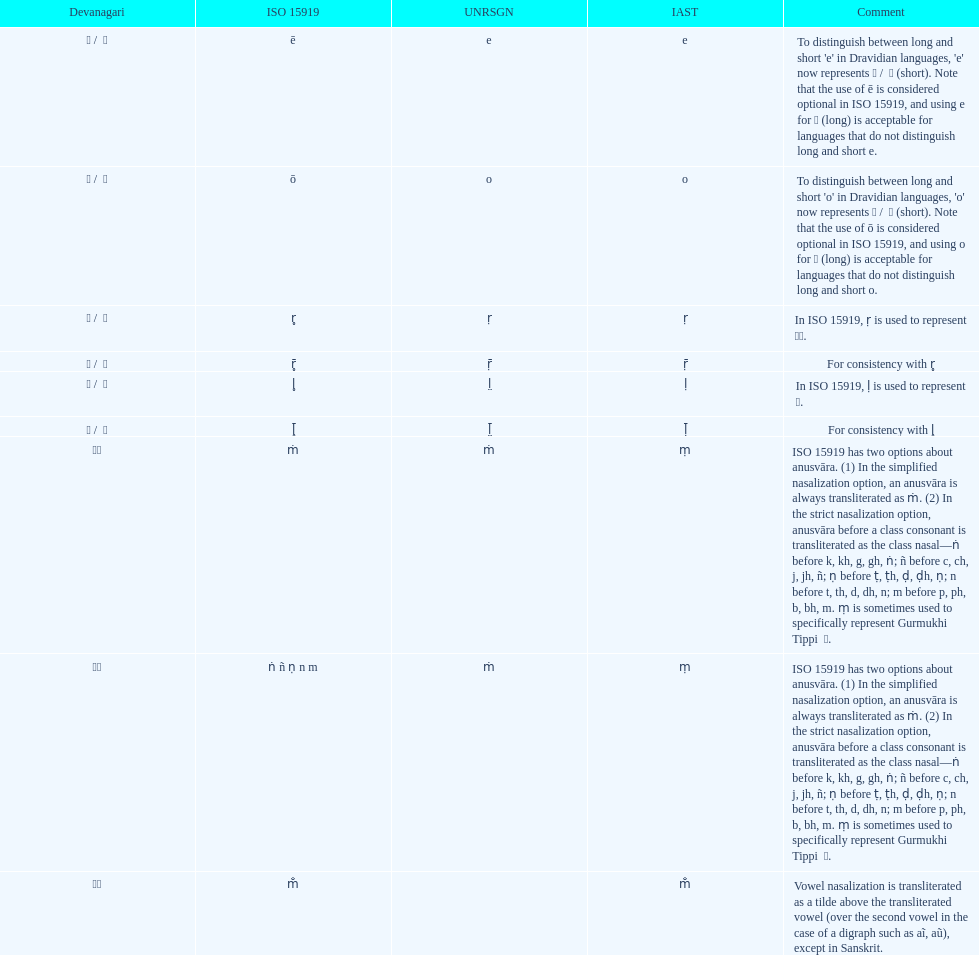What is the total number of translations? 8. 